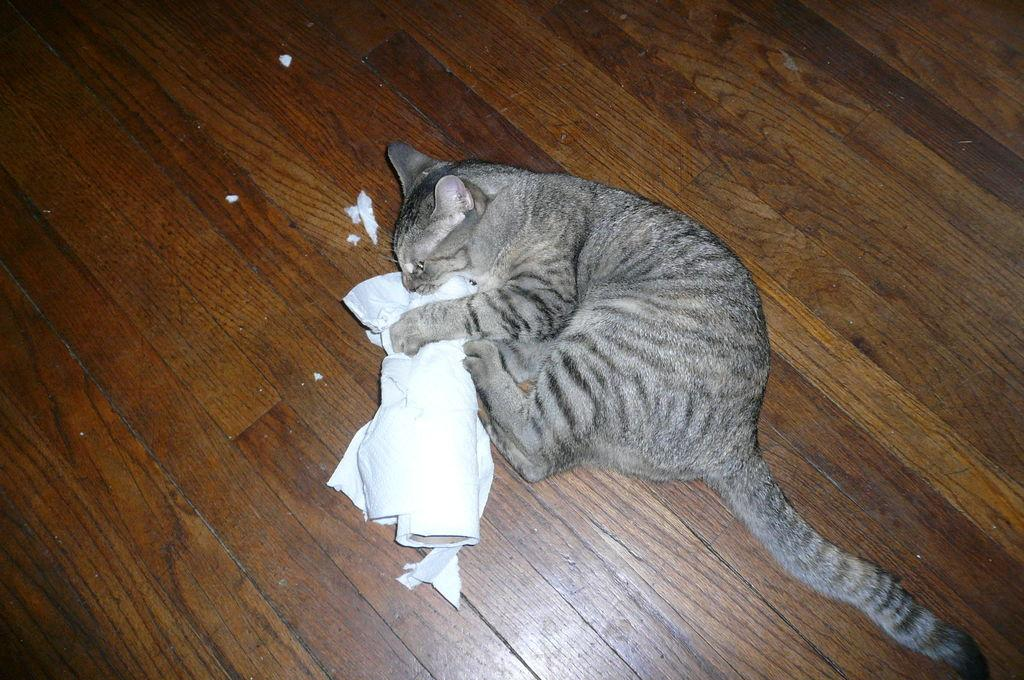What is the main subject of the picture? The main subject of the picture is a cat. What is the cat doing in the picture? The cat is holding a tissue roll. What type of surface is the cat standing on? The cat is on a wooden floor. What type of wire can be seen in the shape of a book in the image? There is no wire or book present in the image; it features a cat holding a tissue roll on a wooden floor. 